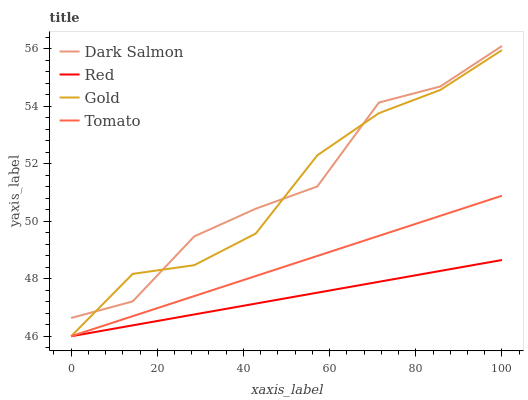Does Gold have the minimum area under the curve?
Answer yes or no. No. Does Gold have the maximum area under the curve?
Answer yes or no. No. Is Gold the smoothest?
Answer yes or no. No. Is Gold the roughest?
Answer yes or no. No. Does Dark Salmon have the lowest value?
Answer yes or no. No. Does Gold have the highest value?
Answer yes or no. No. Is Tomato less than Dark Salmon?
Answer yes or no. Yes. Is Dark Salmon greater than Red?
Answer yes or no. Yes. Does Tomato intersect Dark Salmon?
Answer yes or no. No. 